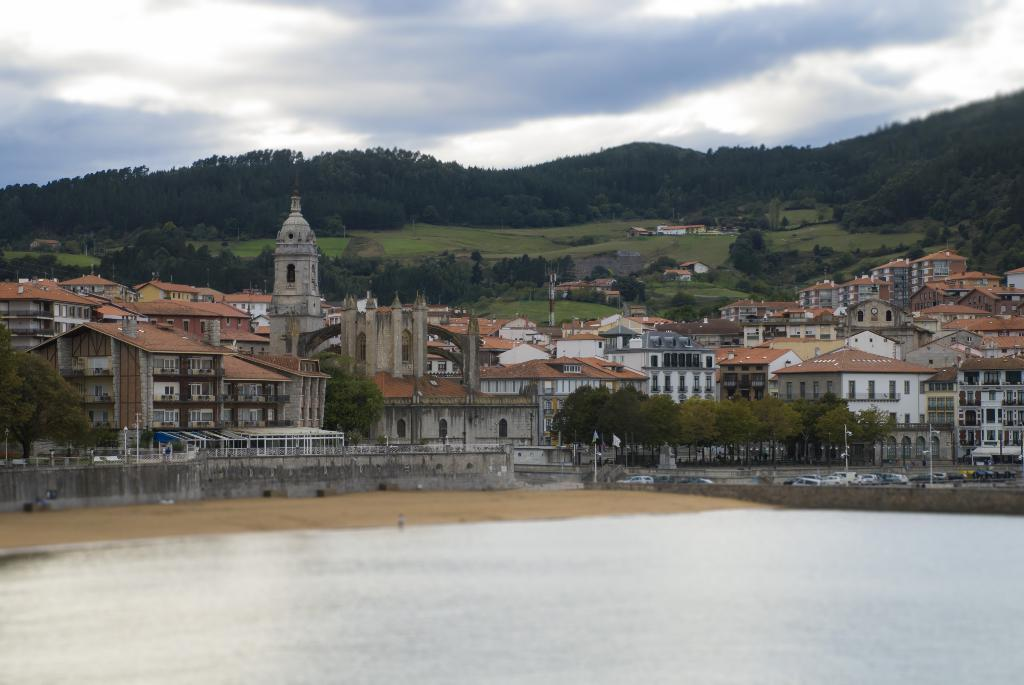What type of structures can be seen in the image? There are buildings in the image. What natural elements are present in the image? There are trees and clouds in the image. What is visible in the background of the image? The sky is visible in the image. What man-made objects can be seen in the image? There are vehicles and poles in the image. What type of produce is being harvested by the hand in the image? There is no produce or hand present in the image. What reaction can be observed from the people in the image after witnessing the event? There are no people or events depicted in the image, so no reactions can be observed. 